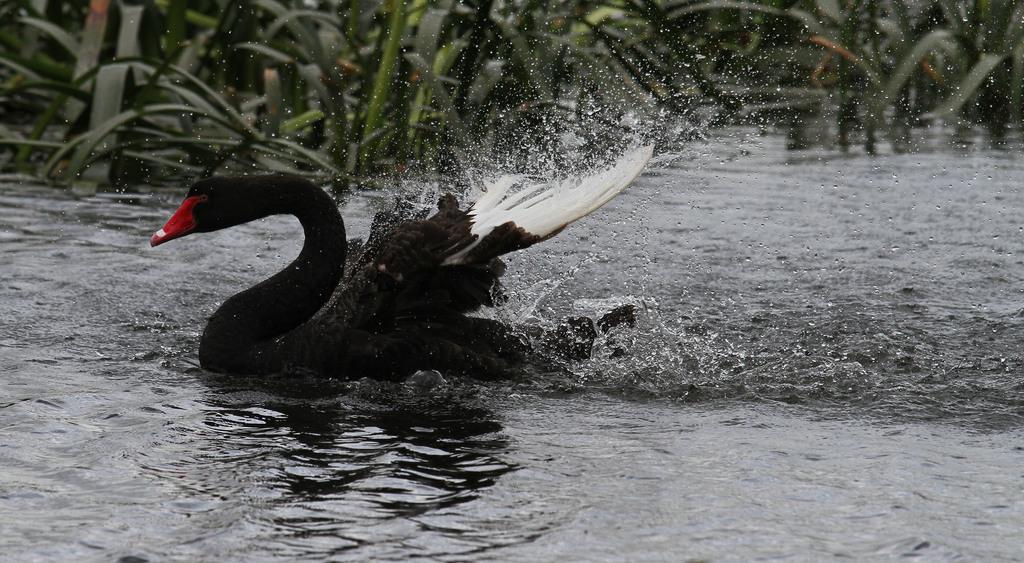How would you summarize this image in a sentence or two? In this image I can see a swan in the water. In the background, I can see the plants. 